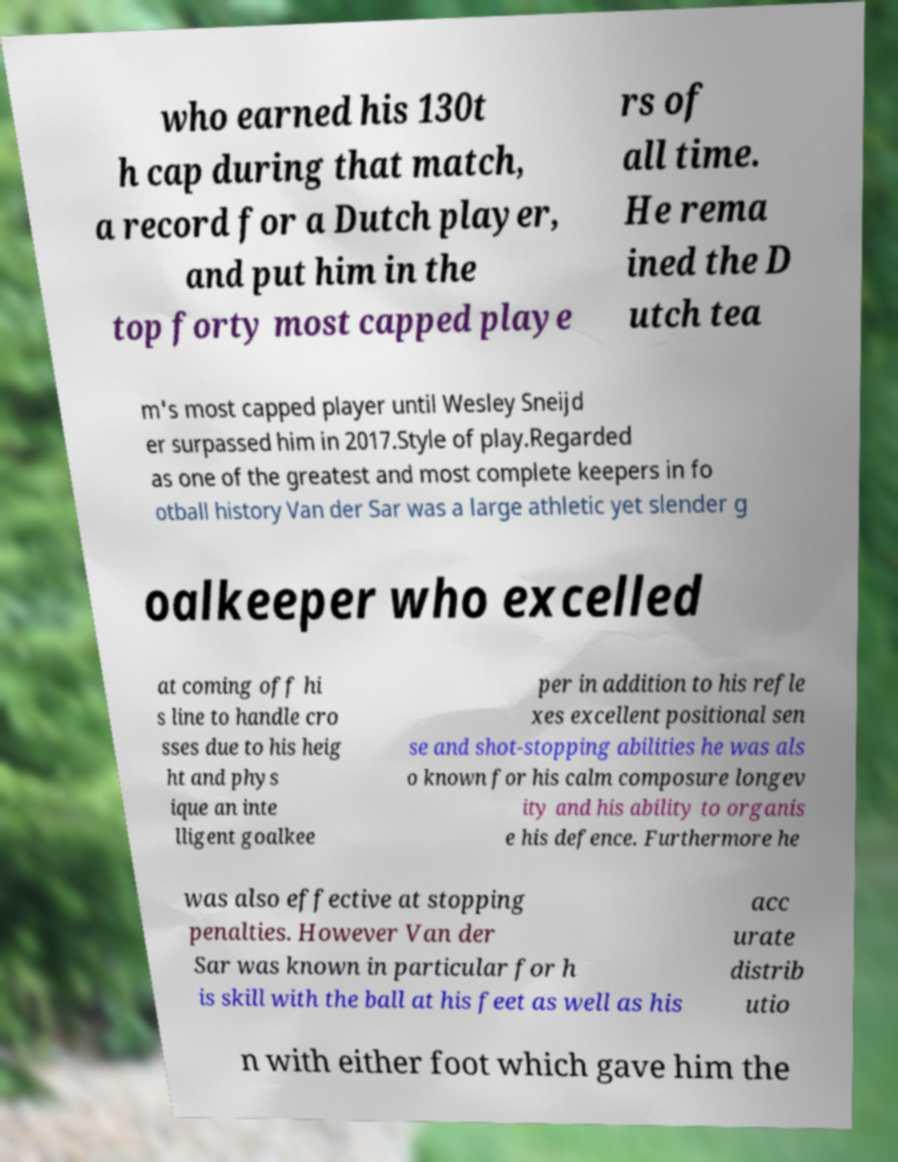Can you accurately transcribe the text from the provided image for me? who earned his 130t h cap during that match, a record for a Dutch player, and put him in the top forty most capped playe rs of all time. He rema ined the D utch tea m's most capped player until Wesley Sneijd er surpassed him in 2017.Style of play.Regarded as one of the greatest and most complete keepers in fo otball history Van der Sar was a large athletic yet slender g oalkeeper who excelled at coming off hi s line to handle cro sses due to his heig ht and phys ique an inte lligent goalkee per in addition to his refle xes excellent positional sen se and shot-stopping abilities he was als o known for his calm composure longev ity and his ability to organis e his defence. Furthermore he was also effective at stopping penalties. However Van der Sar was known in particular for h is skill with the ball at his feet as well as his acc urate distrib utio n with either foot which gave him the 